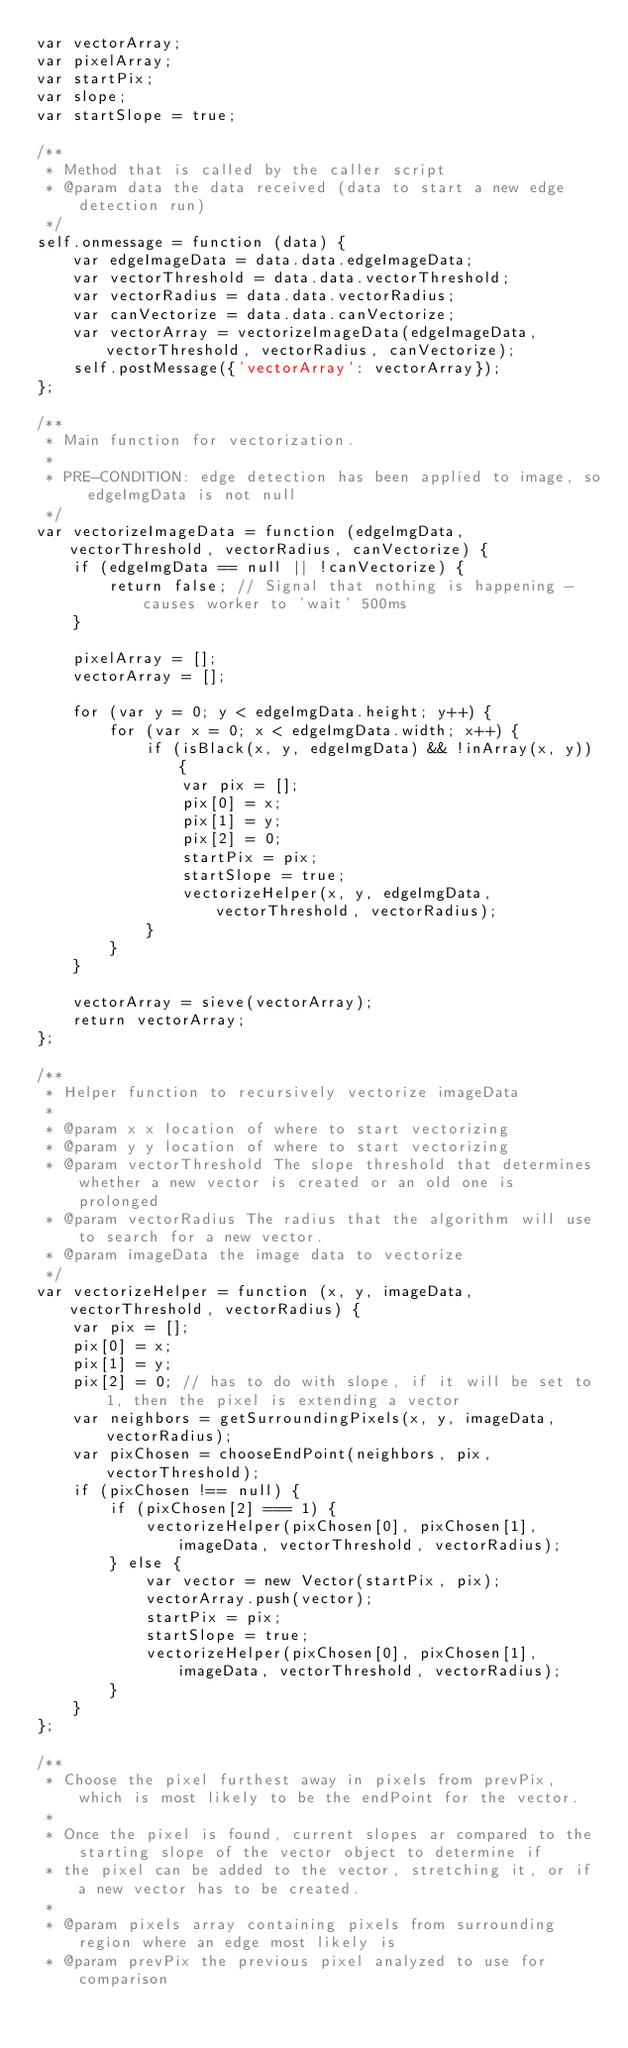Convert code to text. <code><loc_0><loc_0><loc_500><loc_500><_JavaScript_>var vectorArray;
var pixelArray;
var startPix;
var slope;
var startSlope = true;

/**
 * Method that is called by the caller script
 * @param data the data received (data to start a new edge detection run)
 */
self.onmessage = function (data) {
    var edgeImageData = data.data.edgeImageData;
    var vectorThreshold = data.data.vectorThreshold;
    var vectorRadius = data.data.vectorRadius;
    var canVectorize = data.data.canVectorize;
    var vectorArray = vectorizeImageData(edgeImageData, vectorThreshold, vectorRadius, canVectorize);
    self.postMessage({'vectorArray': vectorArray});
};

/**
 * Main function for vectorization.
 *
 * PRE-CONDITION: edge detection has been applied to image, so edgeImgData is not null
 */
var vectorizeImageData = function (edgeImgData, vectorThreshold, vectorRadius, canVectorize) {
    if (edgeImgData == null || !canVectorize) {
        return false; // Signal that nothing is happening - causes worker to 'wait' 500ms
    }

    pixelArray = [];
    vectorArray = [];

    for (var y = 0; y < edgeImgData.height; y++) {
        for (var x = 0; x < edgeImgData.width; x++) {
            if (isBlack(x, y, edgeImgData) && !inArray(x, y)) {
                var pix = [];
                pix[0] = x;
                pix[1] = y;
                pix[2] = 0;
                startPix = pix;
                startSlope = true;
                vectorizeHelper(x, y, edgeImgData, vectorThreshold, vectorRadius);
            }
        }
    }

    vectorArray = sieve(vectorArray);
    return vectorArray;
};

/**
 * Helper function to recursively vectorize imageData
 *
 * @param x x location of where to start vectorizing
 * @param y y location of where to start vectorizing
 * @param vectorThreshold The slope threshold that determines whether a new vector is created or an old one is prolonged
 * @param vectorRadius The radius that the algorithm will use to search for a new vector.
 * @param imageData the image data to vectorize
 */
var vectorizeHelper = function (x, y, imageData, vectorThreshold, vectorRadius) {
    var pix = [];
    pix[0] = x;
    pix[1] = y;
    pix[2] = 0; // has to do with slope, if it will be set to 1, then the pixel is extending a vector
    var neighbors = getSurroundingPixels(x, y, imageData, vectorRadius);
    var pixChosen = chooseEndPoint(neighbors, pix, vectorThreshold);
    if (pixChosen !== null) {
        if (pixChosen[2] === 1) {
            vectorizeHelper(pixChosen[0], pixChosen[1], imageData, vectorThreshold, vectorRadius);
        } else {
            var vector = new Vector(startPix, pix);
            vectorArray.push(vector);
            startPix = pix;
            startSlope = true;
            vectorizeHelper(pixChosen[0], pixChosen[1], imageData, vectorThreshold, vectorRadius);
        }
    }
};

/**
 * Choose the pixel furthest away in pixels from prevPix, which is most likely to be the endPoint for the vector.
 *
 * Once the pixel is found, current slopes ar compared to the starting slope of the vector object to determine if
 * the pixel can be added to the vector, stretching it, or if a new vector has to be created.
 *
 * @param pixels array containing pixels from surrounding region where an edge most likely is
 * @param prevPix the previous pixel analyzed to use for comparison</code> 